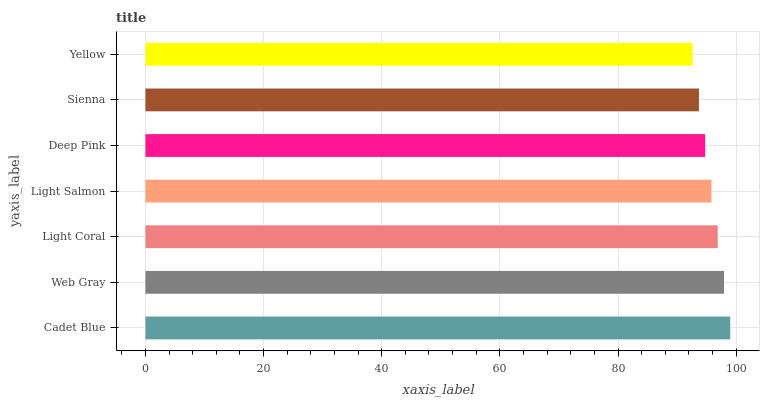Is Yellow the minimum?
Answer yes or no. Yes. Is Cadet Blue the maximum?
Answer yes or no. Yes. Is Web Gray the minimum?
Answer yes or no. No. Is Web Gray the maximum?
Answer yes or no. No. Is Cadet Blue greater than Web Gray?
Answer yes or no. Yes. Is Web Gray less than Cadet Blue?
Answer yes or no. Yes. Is Web Gray greater than Cadet Blue?
Answer yes or no. No. Is Cadet Blue less than Web Gray?
Answer yes or no. No. Is Light Salmon the high median?
Answer yes or no. Yes. Is Light Salmon the low median?
Answer yes or no. Yes. Is Cadet Blue the high median?
Answer yes or no. No. Is Deep Pink the low median?
Answer yes or no. No. 